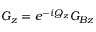Convert formula to latex. <formula><loc_0><loc_0><loc_500><loc_500>G _ { z } = e ^ { - i Q _ { z } } G _ { B z }</formula> 